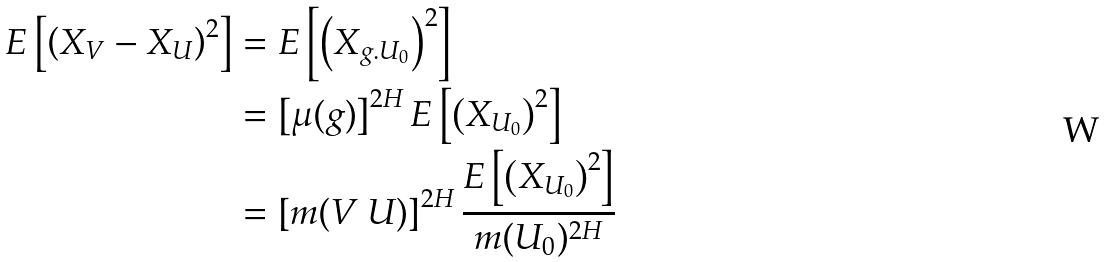Convert formula to latex. <formula><loc_0><loc_0><loc_500><loc_500>E \left [ \left ( X _ { V } - X _ { U } \right ) ^ { 2 } \right ] & = E \left [ \left ( X _ { g . U _ { 0 } } \right ) ^ { 2 } \right ] \\ & = \left [ \mu ( g ) \right ] ^ { 2 H } E \left [ \left ( X _ { U _ { 0 } } \right ) ^ { 2 } \right ] \\ & = \left [ m ( V \ U ) \right ] ^ { 2 H } \frac { E \left [ \left ( X _ { U _ { 0 } } \right ) ^ { 2 } \right ] } { m ( U _ { 0 } ) ^ { 2 H } }</formula> 